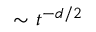<formula> <loc_0><loc_0><loc_500><loc_500>\sim t ^ { - d / 2 }</formula> 